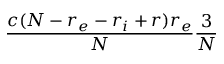<formula> <loc_0><loc_0><loc_500><loc_500>\frac { c ( N - r _ { e } - r _ { i } + r ) r _ { e } } { N } \frac { 3 } { N }</formula> 